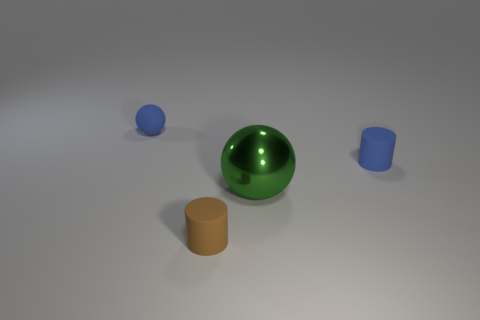There is a rubber thing that is the same color as the matte sphere; what is its shape?
Ensure brevity in your answer.  Cylinder. There is a tiny cylinder that is the same color as the tiny rubber sphere; what is its material?
Make the answer very short. Rubber. Are there any things to the right of the small object that is in front of the blue rubber thing right of the tiny blue rubber sphere?
Keep it short and to the point. Yes. The ball behind the blue thing that is to the right of the small blue matte thing that is left of the large sphere is what color?
Your response must be concise. Blue. What number of tiny blue rubber cylinders are there?
Provide a short and direct response. 1. How many big objects are either green things or balls?
Offer a very short reply. 1. What is the shape of the blue thing that is the same size as the blue cylinder?
Make the answer very short. Sphere. Are there any other things that have the same size as the green ball?
Offer a terse response. No. There is a cylinder on the left side of the blue object on the right side of the large green metallic thing; what is its material?
Make the answer very short. Rubber. Does the green metal thing have the same size as the blue matte ball?
Your response must be concise. No. 